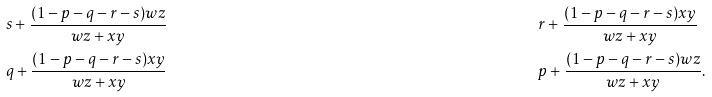<formula> <loc_0><loc_0><loc_500><loc_500>& s + \frac { ( 1 - p - q - r - s ) w z } { w z + x y } & & r + \frac { ( 1 - p - q - r - s ) x y } { w z + x y } \\ & q + \frac { ( 1 - p - q - r - s ) x y } { w z + x y } & & p + \frac { ( 1 - p - q - r - s ) w z } { w z + x y } .</formula> 